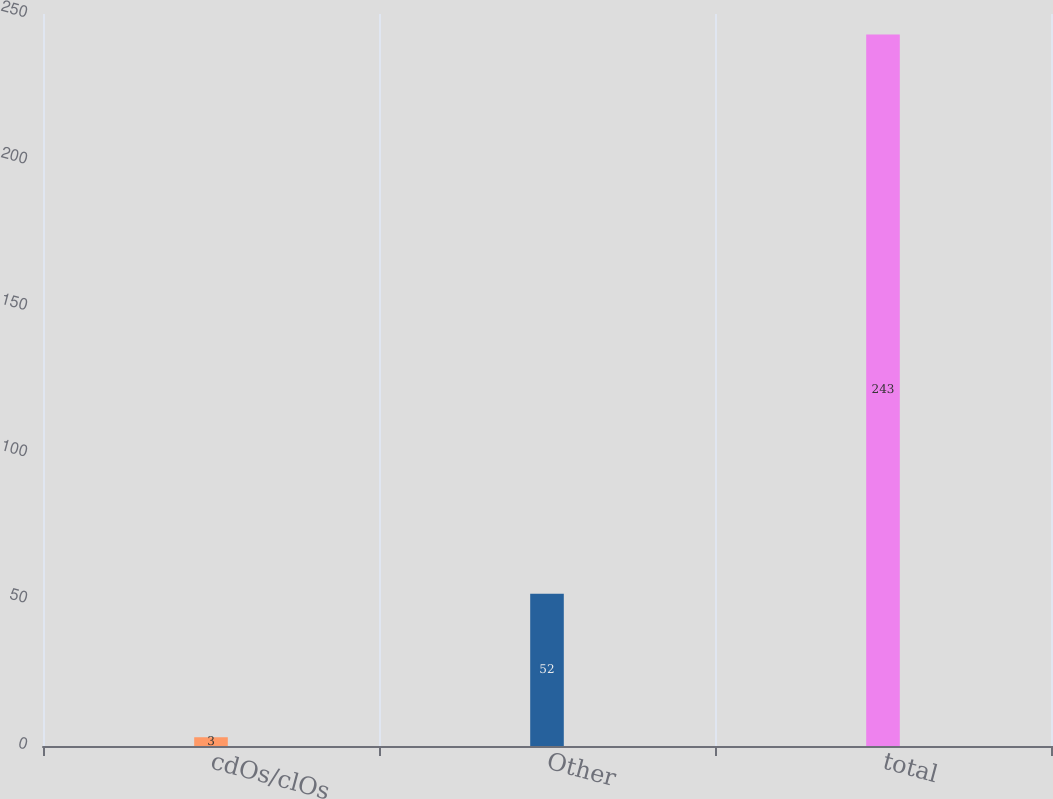Convert chart to OTSL. <chart><loc_0><loc_0><loc_500><loc_500><bar_chart><fcel>cdOs/clOs<fcel>Other<fcel>total<nl><fcel>3<fcel>52<fcel>243<nl></chart> 